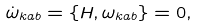<formula> <loc_0><loc_0><loc_500><loc_500>\dot { \omega } _ { k a b } = \left \{ H , \omega _ { k a b } \right \} = 0 ,</formula> 